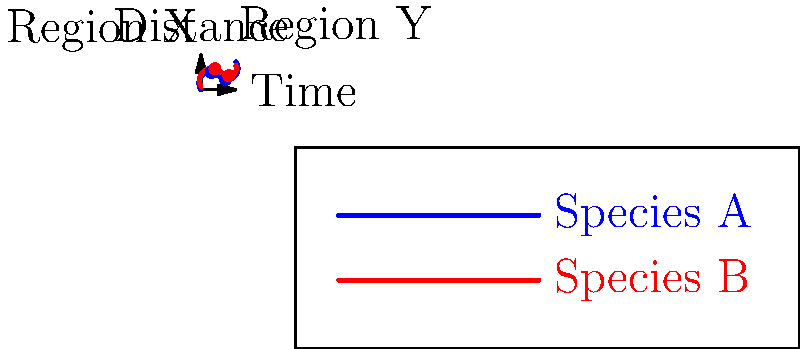Based on the graph showing migration patterns of two endangered species (A and B) derived from satellite imagery and GPS data, which species exhibits a more consistent directional trend in its migration? Explain your reasoning and discuss how this information could be used in conservation efforts. To answer this question, we need to analyze the migration patterns of both species:

1. Examine Species A (blue line):
   - Starts at (0,0)
   - Moves upward to (3,5)
   - Then descends to (7,3)
   - Finally ascends to (10,8)

2. Examine Species B (red line):
   - Starts at (0,1)
   - Moves upward to (4,6)
   - Then descends to (8,4)
   - Finally ascends to (10,7)

3. Compare the patterns:
   - Species A shows more dramatic changes in direction and distance.
   - Species B demonstrates a more gradual and consistent upward trend.

4. Analyze directional consistency:
   - Species B maintains a more consistent overall direction (upward) despite minor fluctuations.
   - Species A has more pronounced changes in direction, making its overall trend less consistent.

5. Consider conservation implications:
   - More consistent migration patterns (like Species B) may indicate:
     a) More stable habitat preferences
     b) Less disruption from environmental changes or human activities
   - This information can be used to:
     a) Identify and protect critical habitats along the migration route
     b) Plan conservation efforts with a focus on maintaining the stability of the migration pattern
     c) Predict future movement and adapt protection strategies accordingly

6. Potential use of satellite imagery (Regions X and Y):
   - Monitor changes in habitat quality or availability in these regions
   - Correlate environmental factors with migration patterns
   - Identify potential threats or barriers to migration

By understanding these migration patterns, conservationists can develop more targeted and effective strategies to protect these endangered species and their habitats.
Answer: Species B; more consistent upward trend despite minor fluctuations, indicating stable habitat preferences and less disruption. 